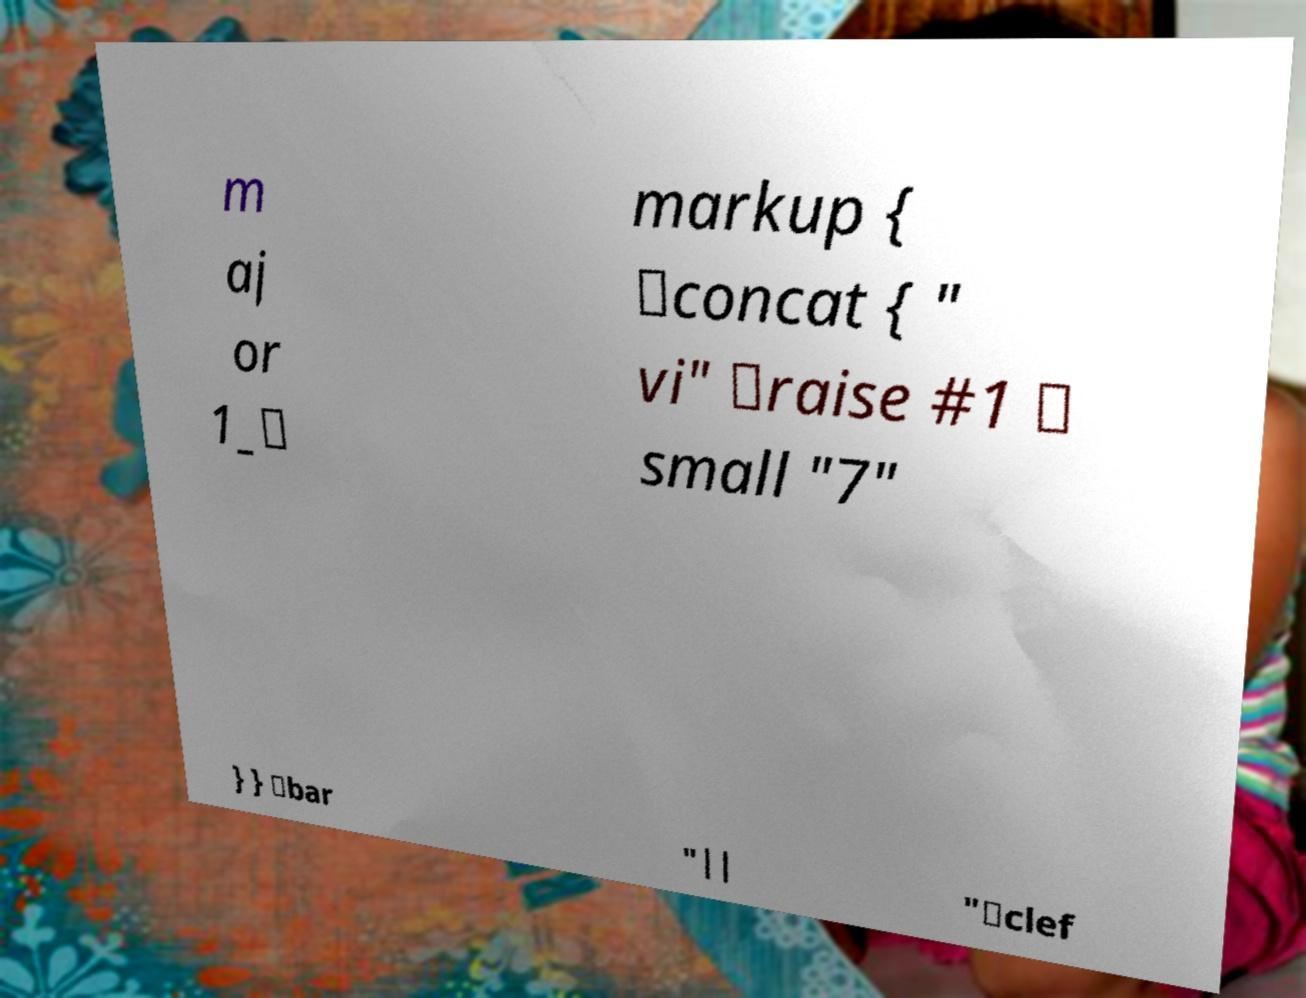Can you read and provide the text displayed in the image?This photo seems to have some interesting text. Can you extract and type it out for me? m aj or 1_\ markup { \concat { " vi" \raise #1 \ small "7" } } \bar "|| "\clef 